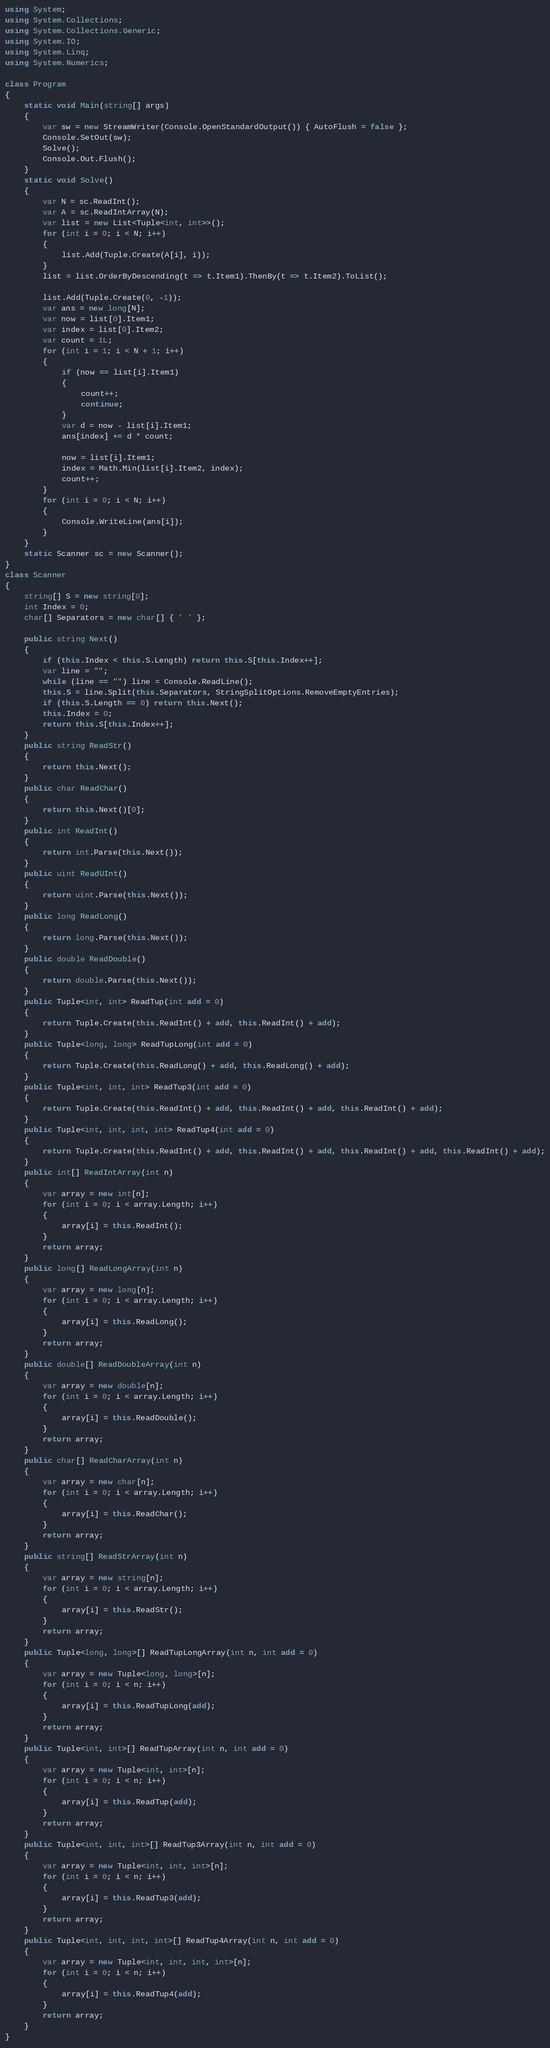<code> <loc_0><loc_0><loc_500><loc_500><_C#_>using System;
using System.Collections;
using System.Collections.Generic;
using System.IO;
using System.Linq;
using System.Numerics;

class Program
{
    static void Main(string[] args)
    {
        var sw = new StreamWriter(Console.OpenStandardOutput()) { AutoFlush = false };
        Console.SetOut(sw);
        Solve();
        Console.Out.Flush();
    }
    static void Solve()
    {
        var N = sc.ReadInt();
        var A = sc.ReadIntArray(N);
        var list = new List<Tuple<int, int>>();
        for (int i = 0; i < N; i++)
        {
            list.Add(Tuple.Create(A[i], i));
        }
        list = list.OrderByDescending(t => t.Item1).ThenBy(t => t.Item2).ToList();

        list.Add(Tuple.Create(0, -1));
        var ans = new long[N];
        var now = list[0].Item1;
        var index = list[0].Item2;
        var count = 1L;
        for (int i = 1; i < N + 1; i++)
        {
            if (now == list[i].Item1)
            {
                count++;
                continue;
            }
            var d = now - list[i].Item1;
            ans[index] += d * count;

            now = list[i].Item1;
            index = Math.Min(list[i].Item2, index);
            count++;
        }
        for (int i = 0; i < N; i++)
        {
            Console.WriteLine(ans[i]);
        }
    }
    static Scanner sc = new Scanner();
}
class Scanner
{
    string[] S = new string[0];
    int Index = 0;
    char[] Separators = new char[] { ' ' };

    public string Next()
    {
        if (this.Index < this.S.Length) return this.S[this.Index++];
        var line = "";
        while (line == "") line = Console.ReadLine();
        this.S = line.Split(this.Separators, StringSplitOptions.RemoveEmptyEntries);
        if (this.S.Length == 0) return this.Next();
        this.Index = 0;
        return this.S[this.Index++];
    }
    public string ReadStr()
    {
        return this.Next();
    }
    public char ReadChar()
    {
        return this.Next()[0];
    }
    public int ReadInt()
    {
        return int.Parse(this.Next());
    }
    public uint ReadUInt()
    {
        return uint.Parse(this.Next());
    }
    public long ReadLong()
    {
        return long.Parse(this.Next());
    }
    public double ReadDouble()
    {
        return double.Parse(this.Next());
    }
    public Tuple<int, int> ReadTup(int add = 0)
    {
        return Tuple.Create(this.ReadInt() + add, this.ReadInt() + add);
    }
    public Tuple<long, long> ReadTupLong(int add = 0)
    {
        return Tuple.Create(this.ReadLong() + add, this.ReadLong() + add);
    }
    public Tuple<int, int, int> ReadTup3(int add = 0)
    {
        return Tuple.Create(this.ReadInt() + add, this.ReadInt() + add, this.ReadInt() + add);
    }
    public Tuple<int, int, int, int> ReadTup4(int add = 0)
    {
        return Tuple.Create(this.ReadInt() + add, this.ReadInt() + add, this.ReadInt() + add, this.ReadInt() + add);
    }
    public int[] ReadIntArray(int n)
    {
        var array = new int[n];
        for (int i = 0; i < array.Length; i++)
        {
            array[i] = this.ReadInt();
        }
        return array;
    }
    public long[] ReadLongArray(int n)
    {
        var array = new long[n];
        for (int i = 0; i < array.Length; i++)
        {
            array[i] = this.ReadLong();
        }
        return array;
    }
    public double[] ReadDoubleArray(int n)
    {
        var array = new double[n];
        for (int i = 0; i < array.Length; i++)
        {
            array[i] = this.ReadDouble();
        }
        return array;
    }
    public char[] ReadCharArray(int n)
    {
        var array = new char[n];
        for (int i = 0; i < array.Length; i++)
        {
            array[i] = this.ReadChar();
        }
        return array;
    }
    public string[] ReadStrArray(int n)
    {
        var array = new string[n];
        for (int i = 0; i < array.Length; i++)
        {
            array[i] = this.ReadStr();
        }
        return array;
    }
    public Tuple<long, long>[] ReadTupLongArray(int n, int add = 0)
    {
        var array = new Tuple<long, long>[n];
        for (int i = 0; i < n; i++)
        {
            array[i] = this.ReadTupLong(add);
        }
        return array;
    }
    public Tuple<int, int>[] ReadTupArray(int n, int add = 0)
    {
        var array = new Tuple<int, int>[n];
        for (int i = 0; i < n; i++)
        {
            array[i] = this.ReadTup(add);
        }
        return array;
    }
    public Tuple<int, int, int>[] ReadTup3Array(int n, int add = 0)
    {
        var array = new Tuple<int, int, int>[n];
        for (int i = 0; i < n; i++)
        {
            array[i] = this.ReadTup3(add);
        }
        return array;
    }
    public Tuple<int, int, int, int>[] ReadTup4Array(int n, int add = 0)
    {
        var array = new Tuple<int, int, int, int>[n];
        for (int i = 0; i < n; i++)
        {
            array[i] = this.ReadTup4(add);
        }
        return array;
    }
}
</code> 